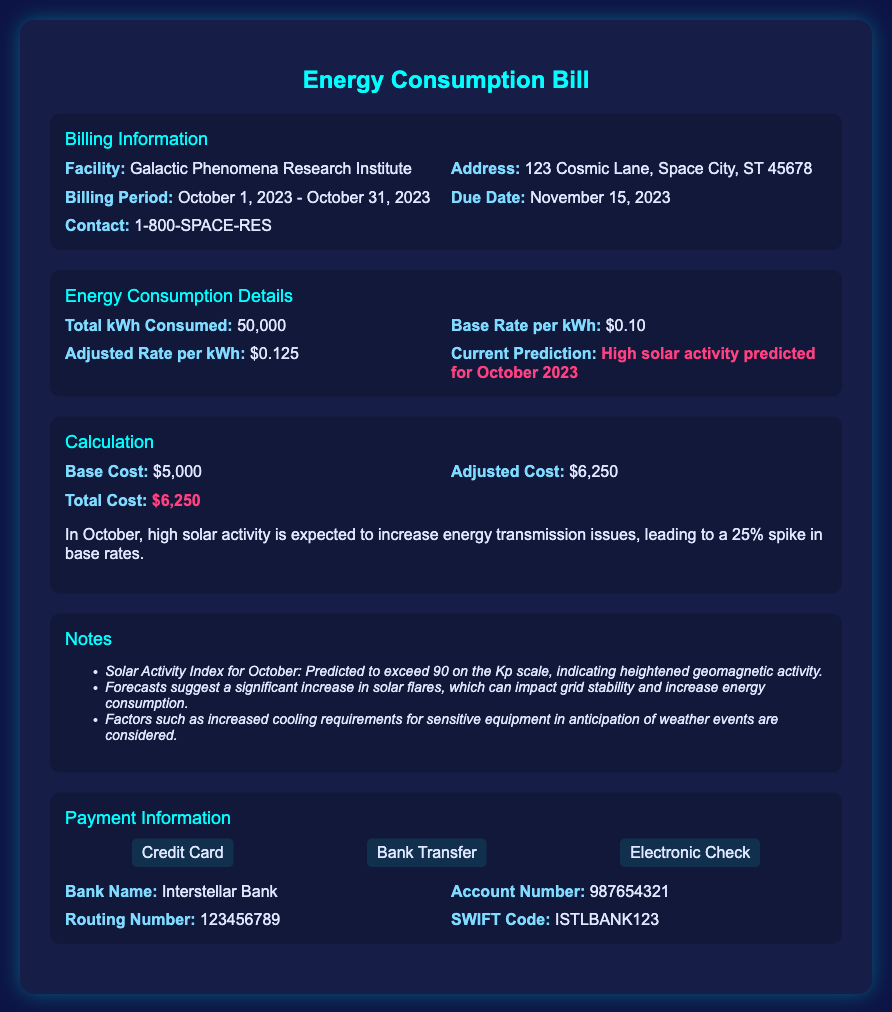What is the total kWh consumed? The document states the total kWh consumed is 50,000.
Answer: 50,000 What is the adjusted rate per kWh? The adjusted rate per kWh is given as $0.125 in the energy consumption details.
Answer: $0.125 What is the total cost indicated in the calculation section? The total cost is highlighted as $6,250 in the calculation section.
Answer: $6,250 What are the payment methods available? The payment methods listed are Credit Card, Bank Transfer, and Electronic Check.
Answer: Credit Card, Bank Transfer, Electronic Check When is the due date for the bill? The due date for the bill is specified as November 15, 2023.
Answer: November 15, 2023 What is the base cost for energy consumption? The base cost for energy consumption is stated as $5,000 in the calculation section.
Answer: $5,000 What is the predicted Solar Activity Index for October? The document mentions the Solar Activity Index is predicted to exceed 90 on the Kp scale.
Answer: Exceed 90 Why is there an increase in the adjusted cost? The adjusted cost has increased due to a 25% spike in base rates due to anticipated high solar activity.
Answer: High solar activity What factors contribute to increased energy consumption? Factors include increased cooling requirements for sensitive equipment and anticipated weather events.
Answer: Increased cooling requirements 